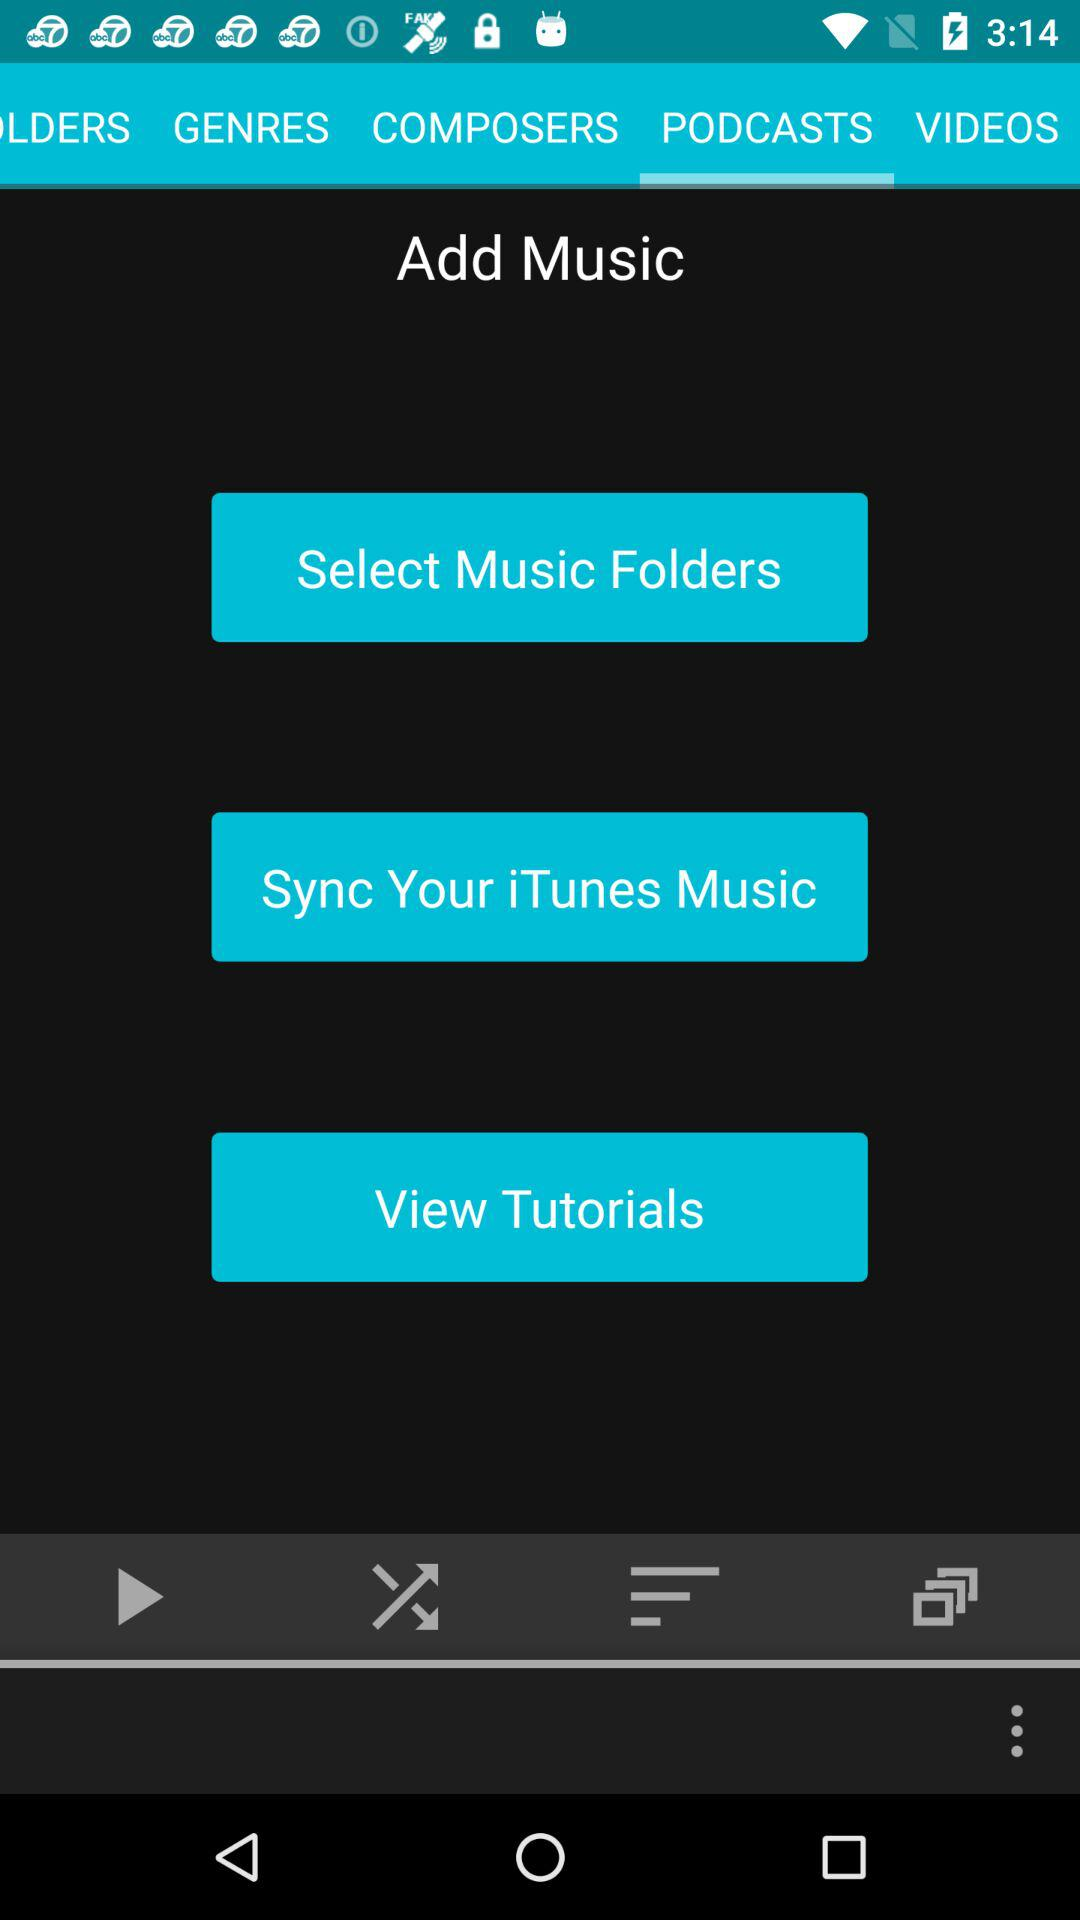Which tab has been selected? The tab that has been selected is "PODCASTS". 